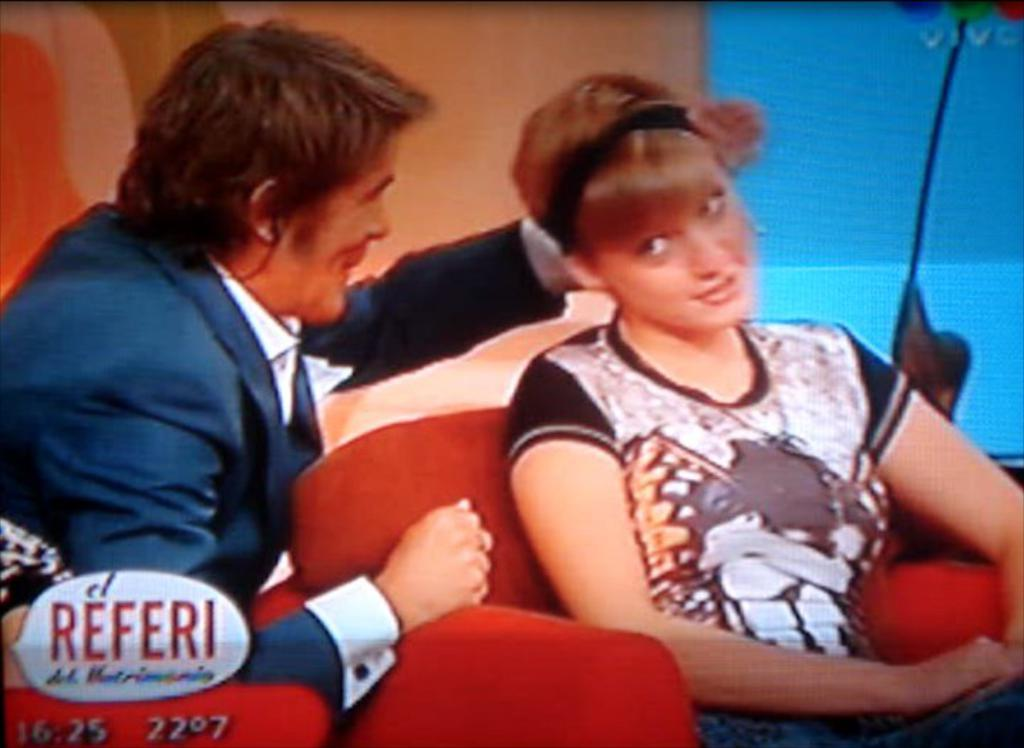What is the gender of the person in the image? There is a man in the image. What is the woman doing in the image? The woman is sitting on a sofa chair in the image. Can you describe any additional elements in the image? There is a watermark in the bottom left corner of the image. How many clocks are visible on the wall in the image? There are no clocks visible on the wall in the image. What type of letters can be seen on the table in the image? There is no table or letters present in the image. 